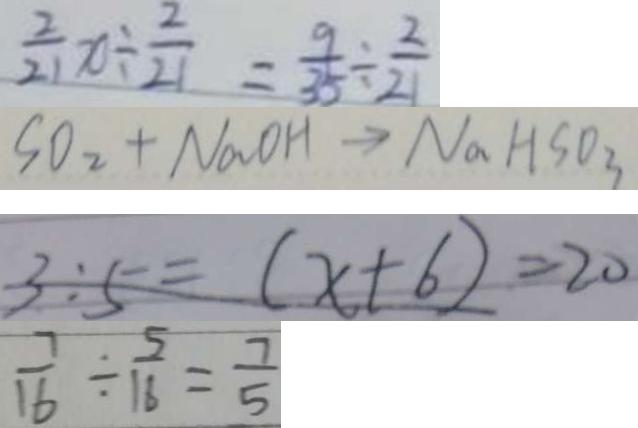Convert formula to latex. <formula><loc_0><loc_0><loc_500><loc_500>\frac { 2 } { 2 1 } x \div \frac { 2 } { 2 1 } = \frac { 9 } { 3 5 } \div \frac { 2 } { 2 1 } 
 S O _ { 2 } + N a O H \rightarrow N a H S O _ { 3 } 
 3 : 5 = ( x + 6 ) = 2 0 
 \frac { 7 } { 1 6 } \div \frac { 5 } { 1 6 } = \frac { 7 } { 5 }</formula> 